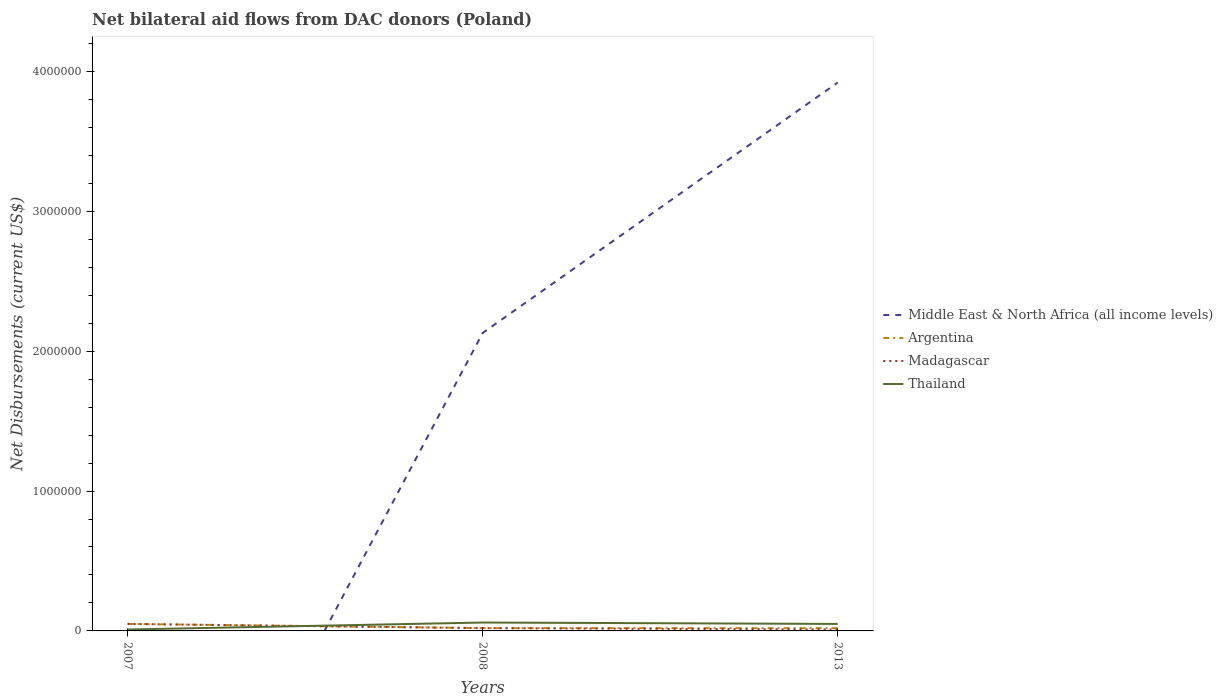Does the line corresponding to Thailand intersect with the line corresponding to Madagascar?
Keep it short and to the point. Yes. What is the difference between the highest and the second highest net bilateral aid flows in Middle East & North Africa (all income levels)?
Keep it short and to the point. 3.92e+06. How many years are there in the graph?
Keep it short and to the point. 3. What is the difference between two consecutive major ticks on the Y-axis?
Offer a terse response. 1.00e+06. Does the graph contain any zero values?
Ensure brevity in your answer.  Yes. Where does the legend appear in the graph?
Ensure brevity in your answer.  Center right. How are the legend labels stacked?
Ensure brevity in your answer.  Vertical. What is the title of the graph?
Give a very brief answer. Net bilateral aid flows from DAC donors (Poland). Does "Latvia" appear as one of the legend labels in the graph?
Provide a succinct answer. No. What is the label or title of the X-axis?
Your response must be concise. Years. What is the label or title of the Y-axis?
Keep it short and to the point. Net Disbursements (current US$). What is the Net Disbursements (current US$) of Middle East & North Africa (all income levels) in 2007?
Keep it short and to the point. 0. What is the Net Disbursements (current US$) in Argentina in 2007?
Give a very brief answer. 5.00e+04. What is the Net Disbursements (current US$) in Middle East & North Africa (all income levels) in 2008?
Your answer should be compact. 2.13e+06. What is the Net Disbursements (current US$) in Argentina in 2008?
Your answer should be compact. 2.00e+04. What is the Net Disbursements (current US$) of Madagascar in 2008?
Offer a terse response. 2.00e+04. What is the Net Disbursements (current US$) in Middle East & North Africa (all income levels) in 2013?
Make the answer very short. 3.92e+06. What is the Net Disbursements (current US$) in Argentina in 2013?
Keep it short and to the point. 2.00e+04. What is the Net Disbursements (current US$) in Madagascar in 2013?
Provide a succinct answer. 10000. Across all years, what is the maximum Net Disbursements (current US$) in Middle East & North Africa (all income levels)?
Provide a short and direct response. 3.92e+06. Across all years, what is the minimum Net Disbursements (current US$) of Middle East & North Africa (all income levels)?
Provide a short and direct response. 0. Across all years, what is the minimum Net Disbursements (current US$) of Madagascar?
Your response must be concise. 10000. What is the total Net Disbursements (current US$) of Middle East & North Africa (all income levels) in the graph?
Provide a succinct answer. 6.05e+06. What is the total Net Disbursements (current US$) of Argentina in the graph?
Your response must be concise. 9.00e+04. What is the difference between the Net Disbursements (current US$) of Argentina in 2007 and that in 2008?
Give a very brief answer. 3.00e+04. What is the difference between the Net Disbursements (current US$) in Thailand in 2007 and that in 2008?
Offer a very short reply. -5.00e+04. What is the difference between the Net Disbursements (current US$) of Madagascar in 2007 and that in 2013?
Offer a terse response. 4.00e+04. What is the difference between the Net Disbursements (current US$) in Middle East & North Africa (all income levels) in 2008 and that in 2013?
Keep it short and to the point. -1.79e+06. What is the difference between the Net Disbursements (current US$) of Argentina in 2008 and that in 2013?
Provide a succinct answer. 0. What is the difference between the Net Disbursements (current US$) in Madagascar in 2008 and that in 2013?
Offer a terse response. 10000. What is the difference between the Net Disbursements (current US$) of Thailand in 2008 and that in 2013?
Offer a terse response. 10000. What is the difference between the Net Disbursements (current US$) in Argentina in 2007 and the Net Disbursements (current US$) in Thailand in 2013?
Offer a very short reply. 0. What is the difference between the Net Disbursements (current US$) in Madagascar in 2007 and the Net Disbursements (current US$) in Thailand in 2013?
Offer a terse response. 0. What is the difference between the Net Disbursements (current US$) in Middle East & North Africa (all income levels) in 2008 and the Net Disbursements (current US$) in Argentina in 2013?
Keep it short and to the point. 2.11e+06. What is the difference between the Net Disbursements (current US$) in Middle East & North Africa (all income levels) in 2008 and the Net Disbursements (current US$) in Madagascar in 2013?
Ensure brevity in your answer.  2.12e+06. What is the difference between the Net Disbursements (current US$) of Middle East & North Africa (all income levels) in 2008 and the Net Disbursements (current US$) of Thailand in 2013?
Your answer should be very brief. 2.08e+06. What is the difference between the Net Disbursements (current US$) of Argentina in 2008 and the Net Disbursements (current US$) of Thailand in 2013?
Your answer should be compact. -3.00e+04. What is the difference between the Net Disbursements (current US$) of Madagascar in 2008 and the Net Disbursements (current US$) of Thailand in 2013?
Offer a terse response. -3.00e+04. What is the average Net Disbursements (current US$) of Middle East & North Africa (all income levels) per year?
Make the answer very short. 2.02e+06. What is the average Net Disbursements (current US$) in Argentina per year?
Offer a terse response. 3.00e+04. What is the average Net Disbursements (current US$) in Madagascar per year?
Provide a short and direct response. 2.67e+04. In the year 2007, what is the difference between the Net Disbursements (current US$) in Argentina and Net Disbursements (current US$) in Madagascar?
Give a very brief answer. 0. In the year 2007, what is the difference between the Net Disbursements (current US$) of Argentina and Net Disbursements (current US$) of Thailand?
Offer a terse response. 4.00e+04. In the year 2008, what is the difference between the Net Disbursements (current US$) in Middle East & North Africa (all income levels) and Net Disbursements (current US$) in Argentina?
Offer a terse response. 2.11e+06. In the year 2008, what is the difference between the Net Disbursements (current US$) in Middle East & North Africa (all income levels) and Net Disbursements (current US$) in Madagascar?
Ensure brevity in your answer.  2.11e+06. In the year 2008, what is the difference between the Net Disbursements (current US$) in Middle East & North Africa (all income levels) and Net Disbursements (current US$) in Thailand?
Your response must be concise. 2.07e+06. In the year 2008, what is the difference between the Net Disbursements (current US$) of Argentina and Net Disbursements (current US$) of Madagascar?
Offer a very short reply. 0. In the year 2008, what is the difference between the Net Disbursements (current US$) in Argentina and Net Disbursements (current US$) in Thailand?
Your answer should be very brief. -4.00e+04. In the year 2013, what is the difference between the Net Disbursements (current US$) in Middle East & North Africa (all income levels) and Net Disbursements (current US$) in Argentina?
Give a very brief answer. 3.90e+06. In the year 2013, what is the difference between the Net Disbursements (current US$) in Middle East & North Africa (all income levels) and Net Disbursements (current US$) in Madagascar?
Your response must be concise. 3.91e+06. In the year 2013, what is the difference between the Net Disbursements (current US$) of Middle East & North Africa (all income levels) and Net Disbursements (current US$) of Thailand?
Your response must be concise. 3.87e+06. What is the ratio of the Net Disbursements (current US$) of Argentina in 2007 to that in 2008?
Offer a terse response. 2.5. What is the ratio of the Net Disbursements (current US$) of Madagascar in 2007 to that in 2008?
Provide a short and direct response. 2.5. What is the ratio of the Net Disbursements (current US$) of Thailand in 2007 to that in 2008?
Provide a succinct answer. 0.17. What is the ratio of the Net Disbursements (current US$) of Madagascar in 2007 to that in 2013?
Offer a very short reply. 5. What is the ratio of the Net Disbursements (current US$) in Thailand in 2007 to that in 2013?
Provide a succinct answer. 0.2. What is the ratio of the Net Disbursements (current US$) in Middle East & North Africa (all income levels) in 2008 to that in 2013?
Your answer should be very brief. 0.54. What is the ratio of the Net Disbursements (current US$) of Argentina in 2008 to that in 2013?
Your answer should be compact. 1. What is the ratio of the Net Disbursements (current US$) in Thailand in 2008 to that in 2013?
Offer a very short reply. 1.2. What is the difference between the highest and the second highest Net Disbursements (current US$) of Argentina?
Make the answer very short. 3.00e+04. What is the difference between the highest and the lowest Net Disbursements (current US$) of Middle East & North Africa (all income levels)?
Offer a very short reply. 3.92e+06. What is the difference between the highest and the lowest Net Disbursements (current US$) of Argentina?
Your answer should be very brief. 3.00e+04. What is the difference between the highest and the lowest Net Disbursements (current US$) of Thailand?
Your response must be concise. 5.00e+04. 